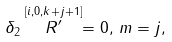<formula> <loc_0><loc_0><loc_500><loc_500>\delta _ { 2 } \stackrel { [ i , 0 , k + j + 1 ] } { R ^ { \prime } } = 0 , \, m = j ,</formula> 